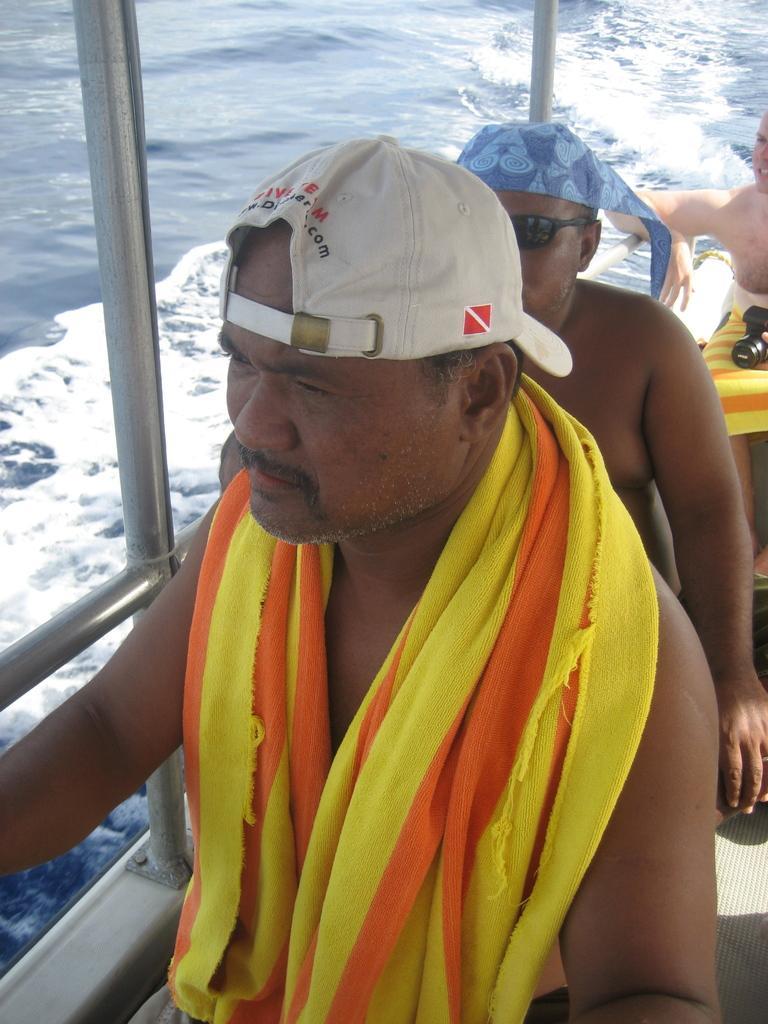How would you summarize this image in a sentence or two? In this image, we can see people in the boat and we can see a cloth on the person and he is wearing a cap. In the background, there is a man wearing glasses and a cloth on him and we can see a camera on other person and there are rods and we can see water. 